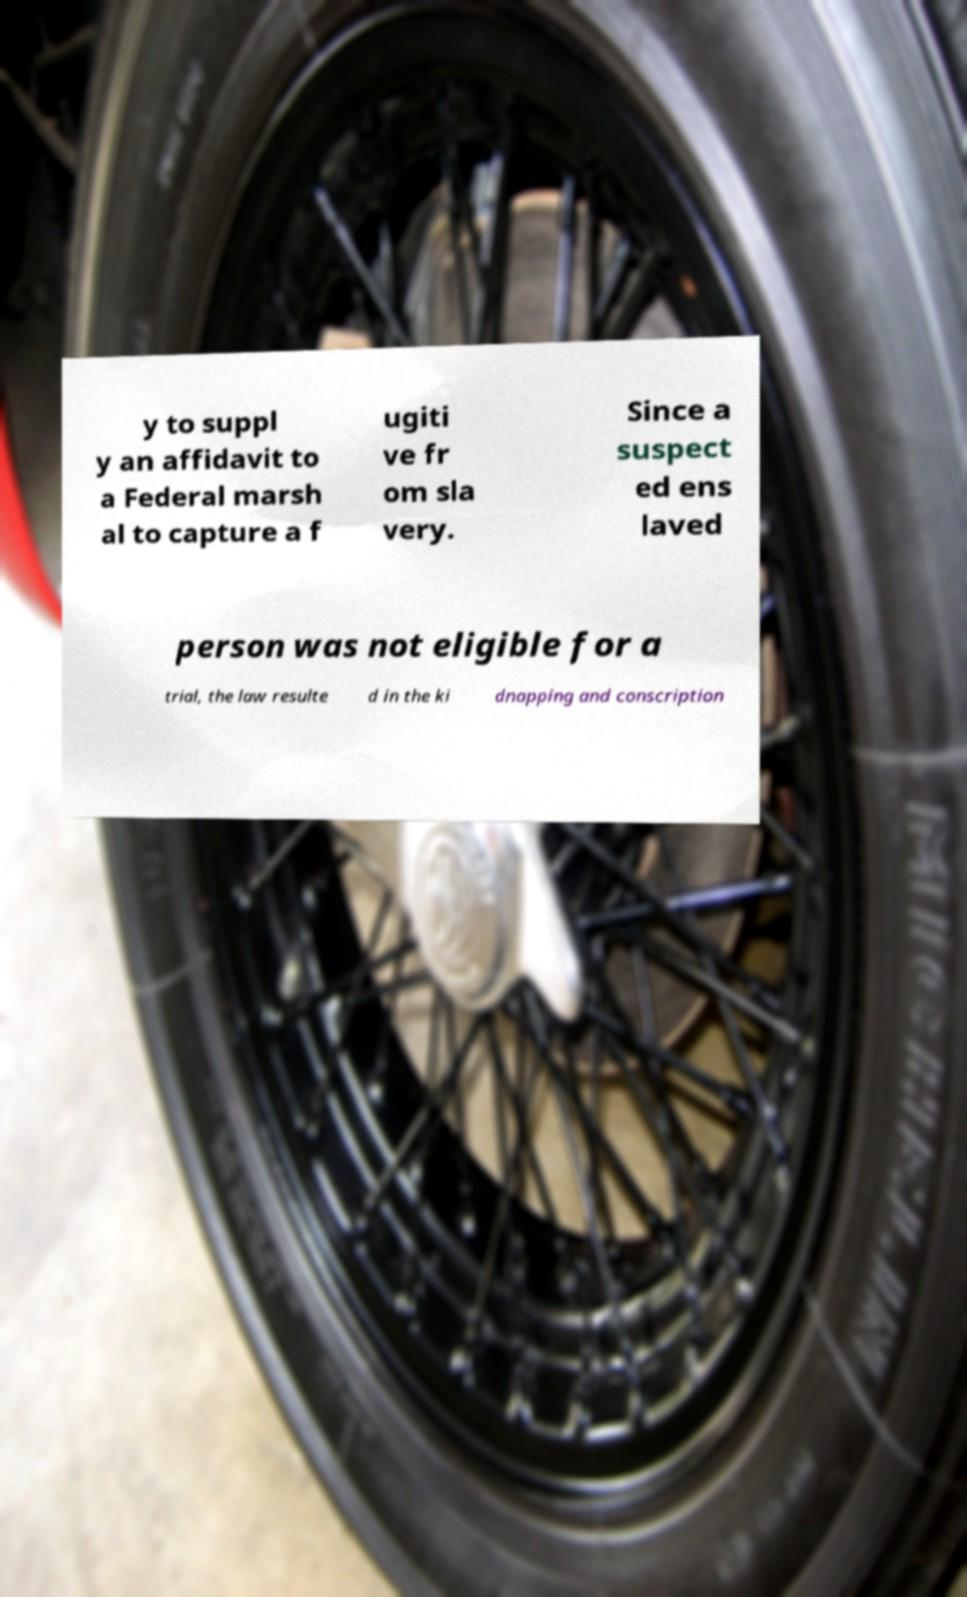Please read and relay the text visible in this image. What does it say? y to suppl y an affidavit to a Federal marsh al to capture a f ugiti ve fr om sla very. Since a suspect ed ens laved person was not eligible for a trial, the law resulte d in the ki dnapping and conscription 